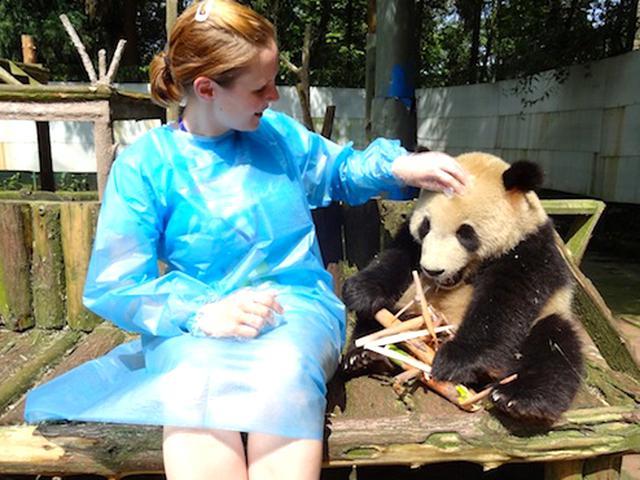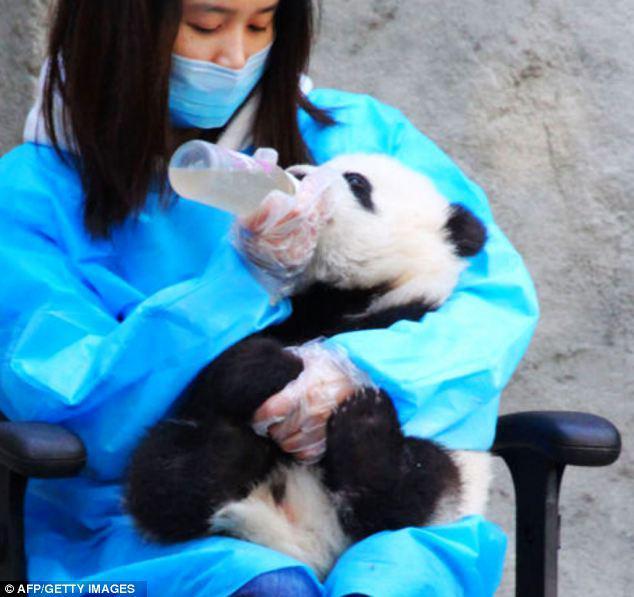The first image is the image on the left, the second image is the image on the right. For the images displayed, is the sentence "In one of the images, there are least two people interacting with a panda bear." factually correct? Answer yes or no. No. The first image is the image on the left, the second image is the image on the right. Assess this claim about the two images: "One of the pandas is being fed a bottle by a person wearing a protective blue garment.". Correct or not? Answer yes or no. Yes. 